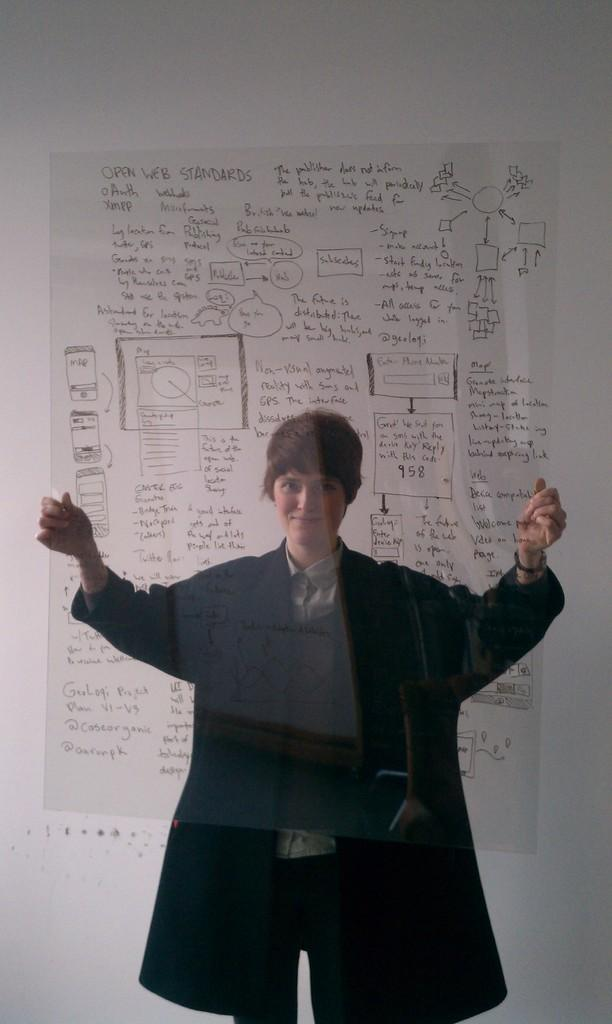What is the main subject of the image? There is a person in the image. What is the person holding in the image? The person is holding a transparent sheet. What can be seen in the background of the image? There is a wall in the background of the image. What color is the hammer in the image? There is no hammer present in the image. What type of space is depicted in the image? The image does not depict any space; it features a person holding a transparent sheet in front of a wall. 